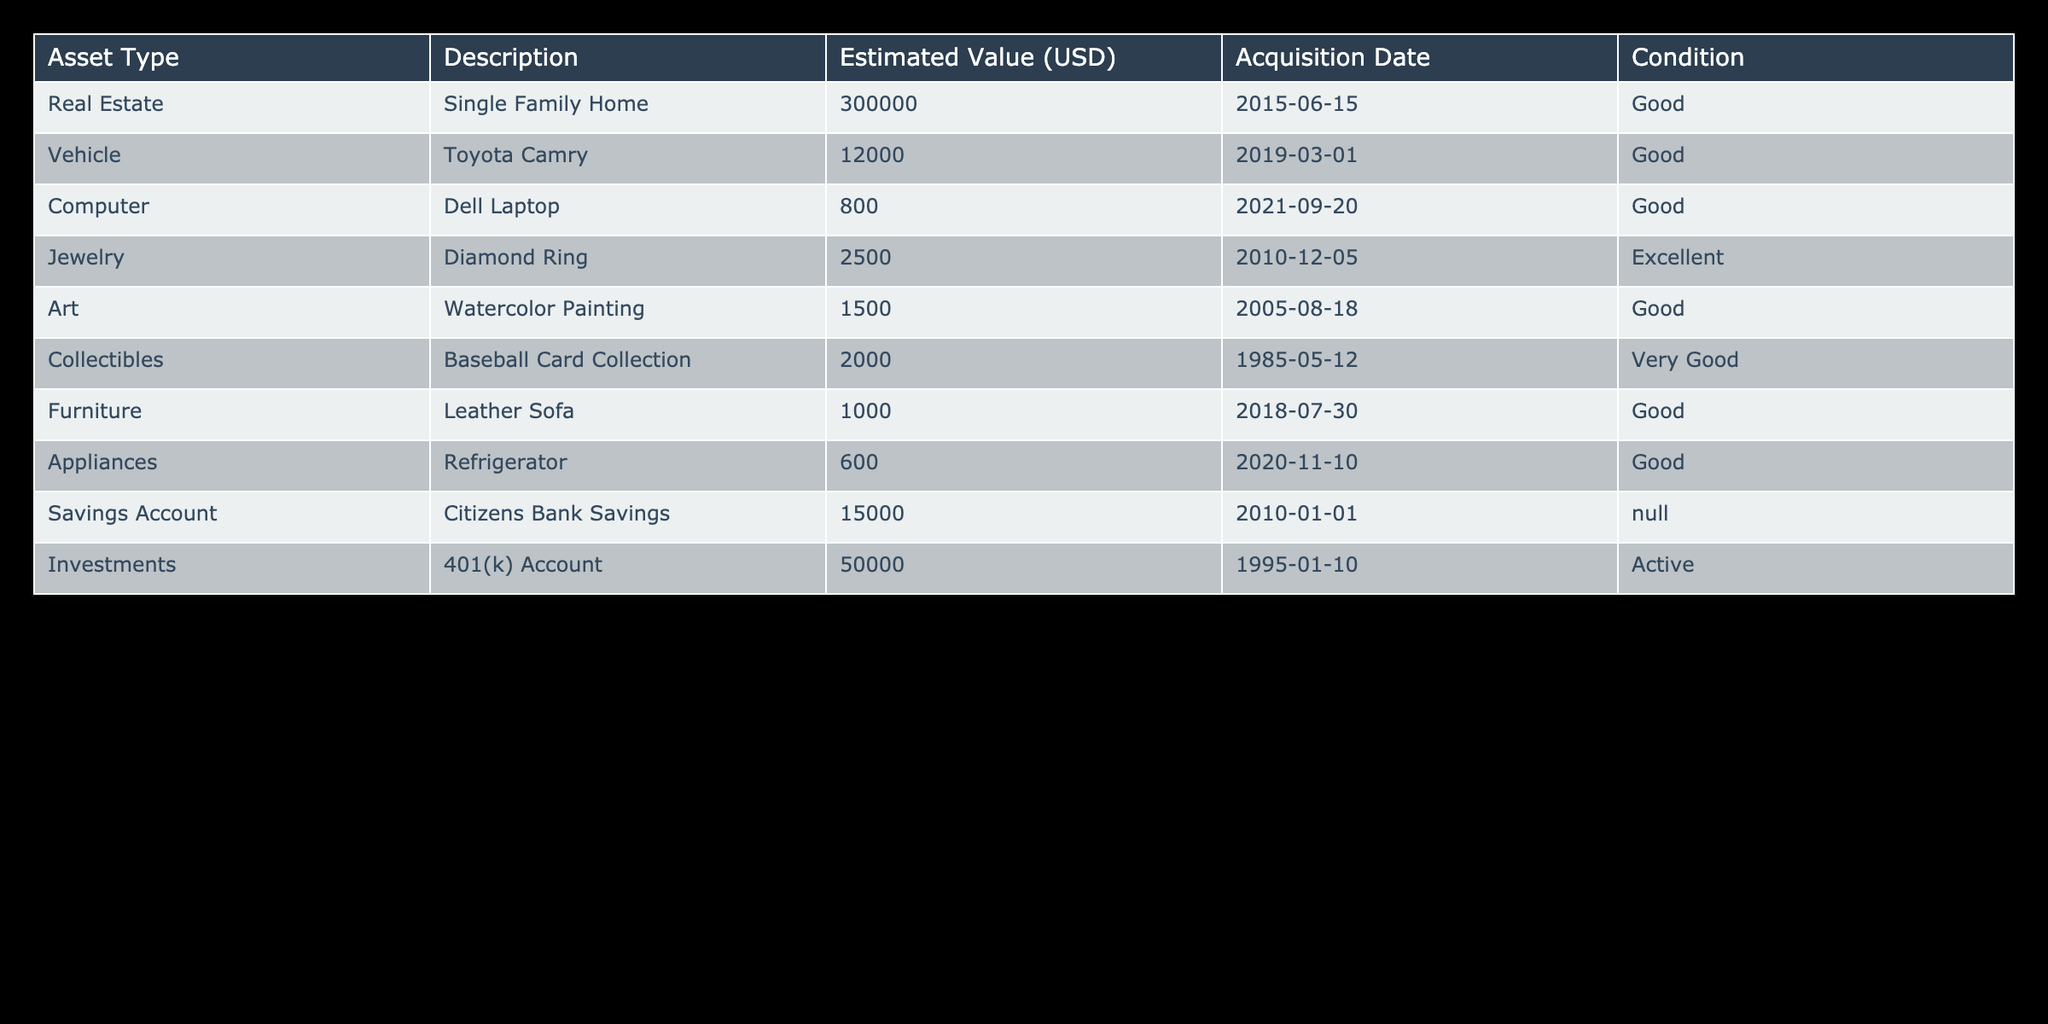What is the estimated value of the single-family home? In the table, under the "Estimated Value (USD)" column, we find that the "Single Family Home" has an estimated value of 300000.
Answer: 300000 How many assets are listed in the inventory? By counting the number of rows in the table (excluding the header), we see that there are 10 assets listed including real estate, vehicles, and others.
Answer: 10 What is the total estimated value of all the assets in the table? The total estimated value is the sum of all individual values: 300000 + 12000 + 800 + 2500 + 1500 + 2000 + 1000 + 600 + 15000 + 50000 = 339402.
Answer: 339402 Is the condition of the Diamond Ring excellent according to the table? The table specifies the condition of the "Diamond Ring" as "Excellent", which confirms that this statement is true.
Answer: Yes What is the average estimated value of all the vehicles listed? The only vehicle in the table is the "Toyota Camry" valued at 12000, so the average value is 12000 since we have only one vehicle.
Answer: 12000 Which asset type has the highest estimated value? The "Real Estate" category contains the "Single Family Home" which has the highest value at 300000 compared to all other assets listed.
Answer: Real Estate What is the combined estimated value of Appliances and Furniture? The estimated value of Appliances (Refrigerator) is 600, and the estimated value of Furniture (Leather Sofa) is 1000. Adding these together gives 600 + 1000 = 1600.
Answer: 1600 Is there a jewelry item that has a higher estimated value than 2000? The only jewelry item is the "Diamond Ring," which is valued at 2500, thus confirming the statement is true.
Answer: Yes How many assets were acquired before the year 2010? The assets acquired before 2010 are the "Baseball Card Collection" (1985) and the "Diamond Ring" (2010). There are 2 such assets.
Answer: 2 